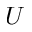<formula> <loc_0><loc_0><loc_500><loc_500>U</formula> 